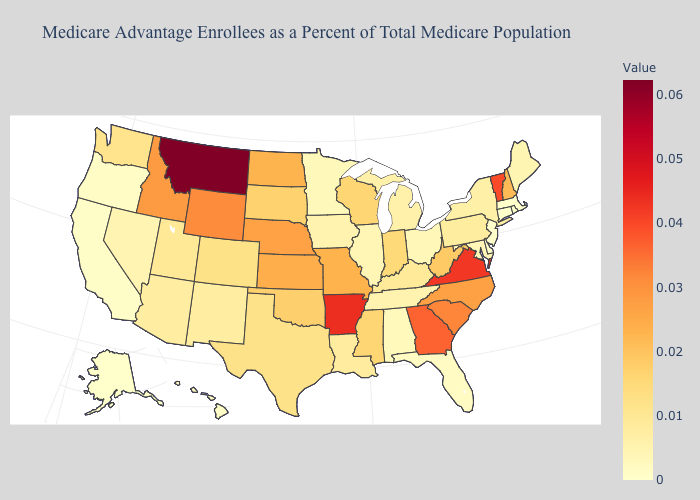Among the states that border New Hampshire , does Massachusetts have the lowest value?
Give a very brief answer. Yes. Which states have the lowest value in the USA?
Keep it brief. Alaska, Connecticut, Delaware, Massachusetts, New Jersey, Rhode Island. Among the states that border Georgia , does Alabama have the highest value?
Be succinct. No. Which states have the lowest value in the USA?
Quick response, please. Alaska, Connecticut, Delaware, Massachusetts, New Jersey, Rhode Island. Which states have the lowest value in the MidWest?
Answer briefly. Minnesota. Does California have the highest value in the West?
Short answer required. No. Does the map have missing data?
Give a very brief answer. No. Is the legend a continuous bar?
Quick response, please. Yes. 